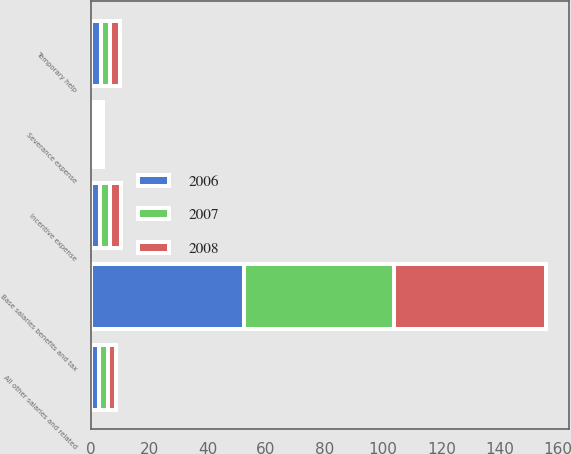<chart> <loc_0><loc_0><loc_500><loc_500><stacked_bar_chart><ecel><fcel>Base salaries benefits and tax<fcel>Incentive expense<fcel>Severance expense<fcel>Temporary help<fcel>All other salaries and related<nl><fcel>2007<fcel>51.6<fcel>3.4<fcel>1.3<fcel>3.1<fcel>3<nl><fcel>2008<fcel>51.9<fcel>3.7<fcel>1.2<fcel>3.5<fcel>2.9<nl><fcel>2006<fcel>52.3<fcel>3.3<fcel>1.6<fcel>3.6<fcel>2.9<nl></chart> 